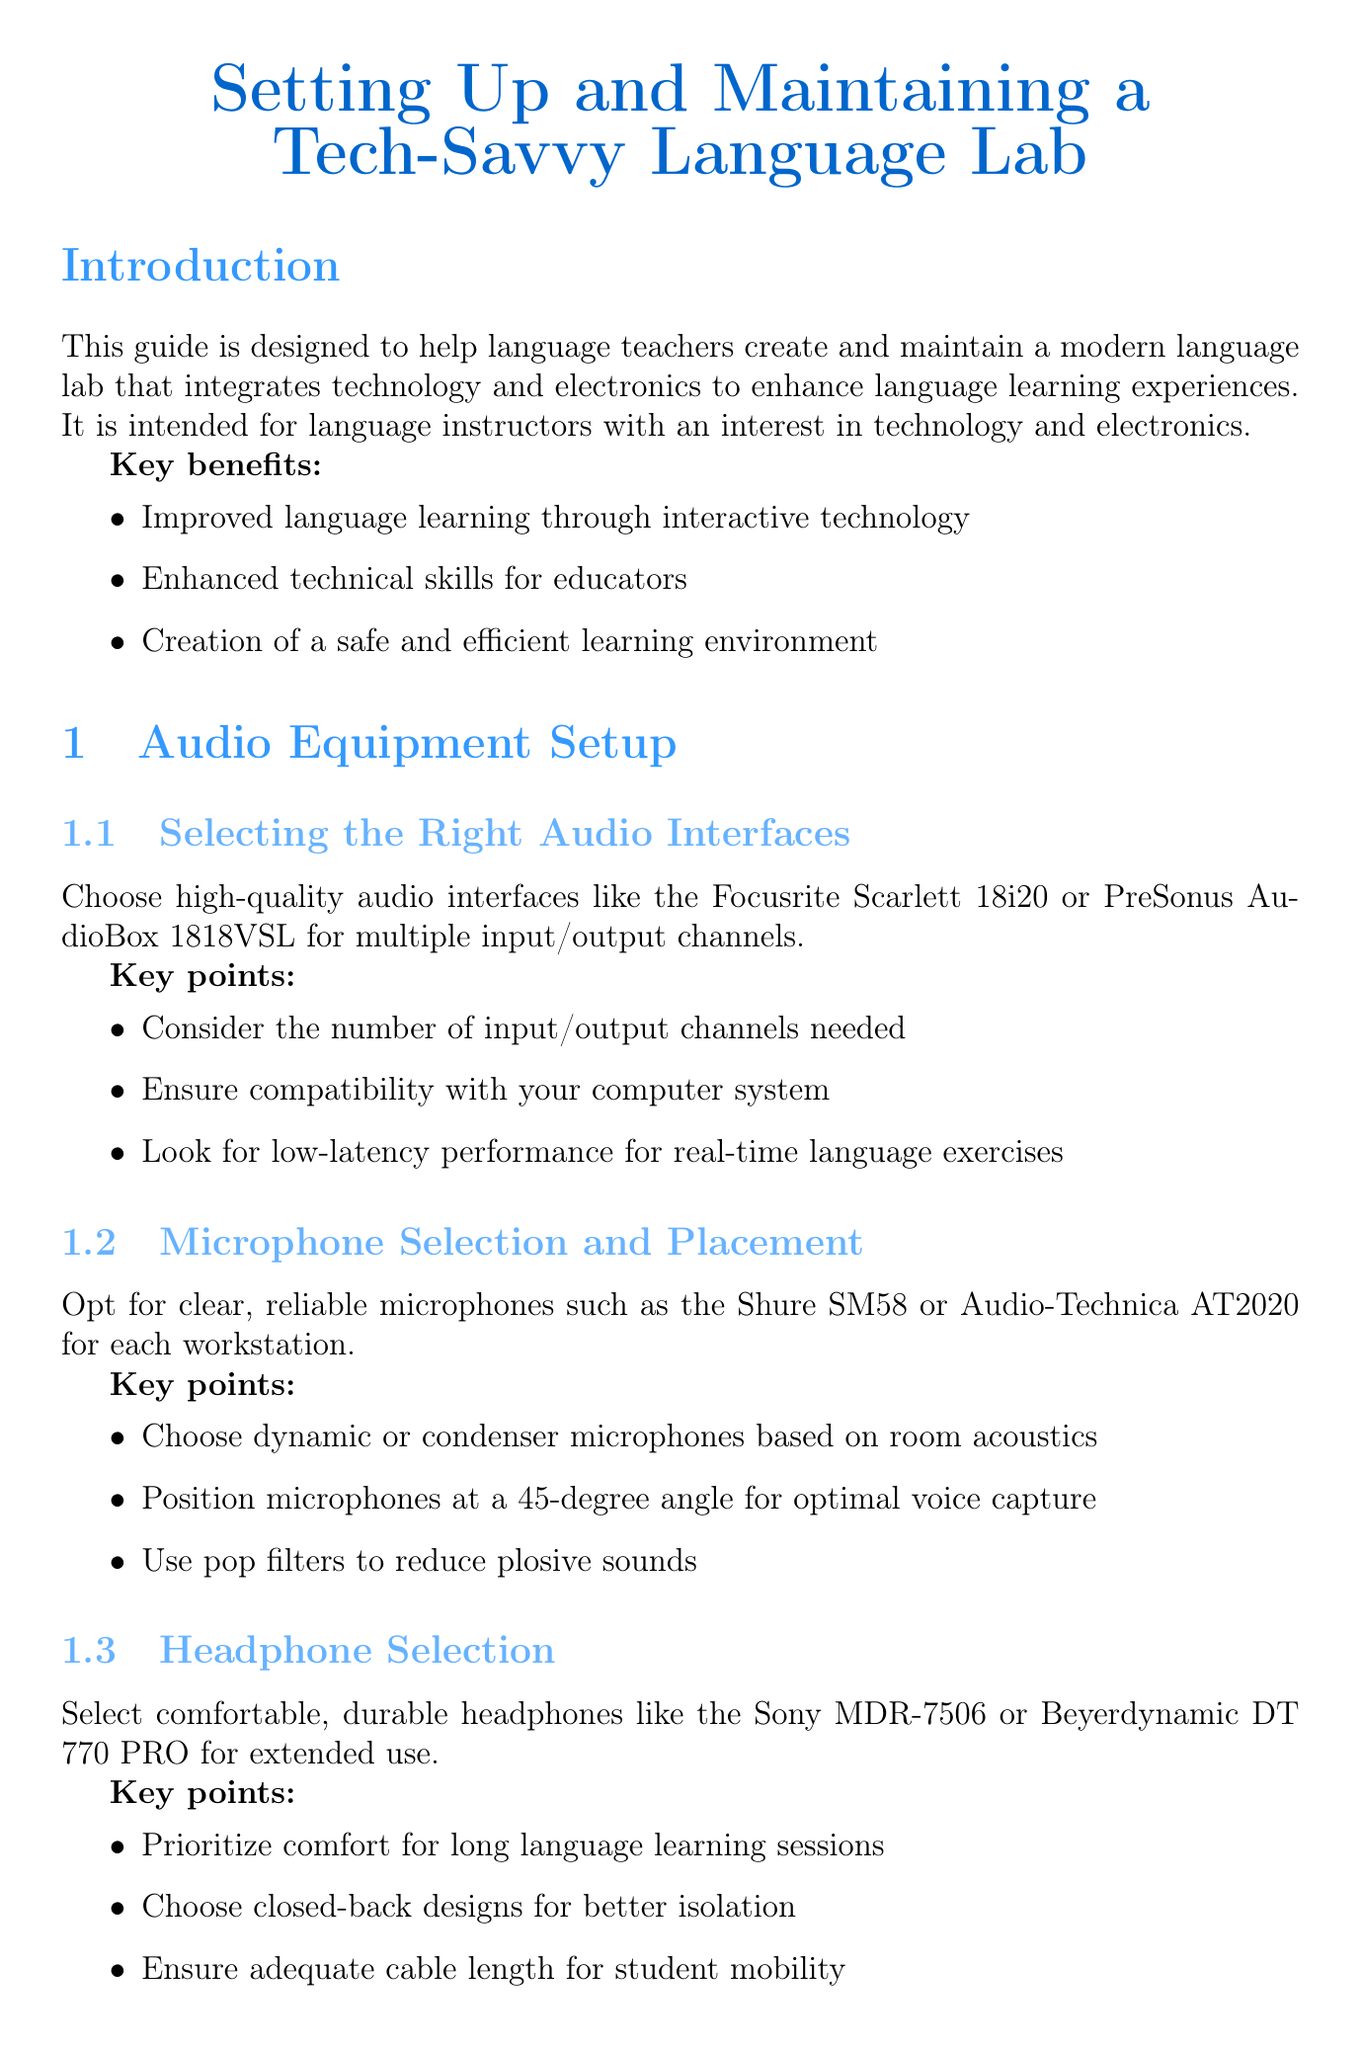What is the title of the manual? The title is specified at the beginning of the document.
Answer: Setting Up and Maintaining a Tech-Savvy Language Lab Who is the target audience for this guide? The target audience is detailed in the introduction of the document.
Answer: Language instructors with an interest in technology and electronics What is the minimum recommended RAM for computers? The document specifies the minimum RAM requirement in the Computer Systems Configuration section.
Answer: 8GB RAM Which microphone model is suggested for the language lab? The recommended microphone model is included in the Audio Equipment Setup section.
Answer: Shure SM58 What type of surge protector is recommended for electrical safety? The document mentions specific surge protectors in the Safety Precautions section.
Answer: APC SurgeArrest How often should audio equipment be cleaned? The recommended cleaning frequency is stated in the Equipment Maintenance Schedule subsection.
Answer: Monthly What software is suggested for audio recording and editing? This information is found in the Software Installation and Configuration section.
Answer: Audacity What should be included in the regular maintenance schedule? The maintenance schedule includes specific activities to ensure performance.
Answer: Equipment checks and calibrations What is a key benefit of the language lab setup? The key benefits are listed in the introduction of the document.
Answer: Improved language learning through interactive technology 